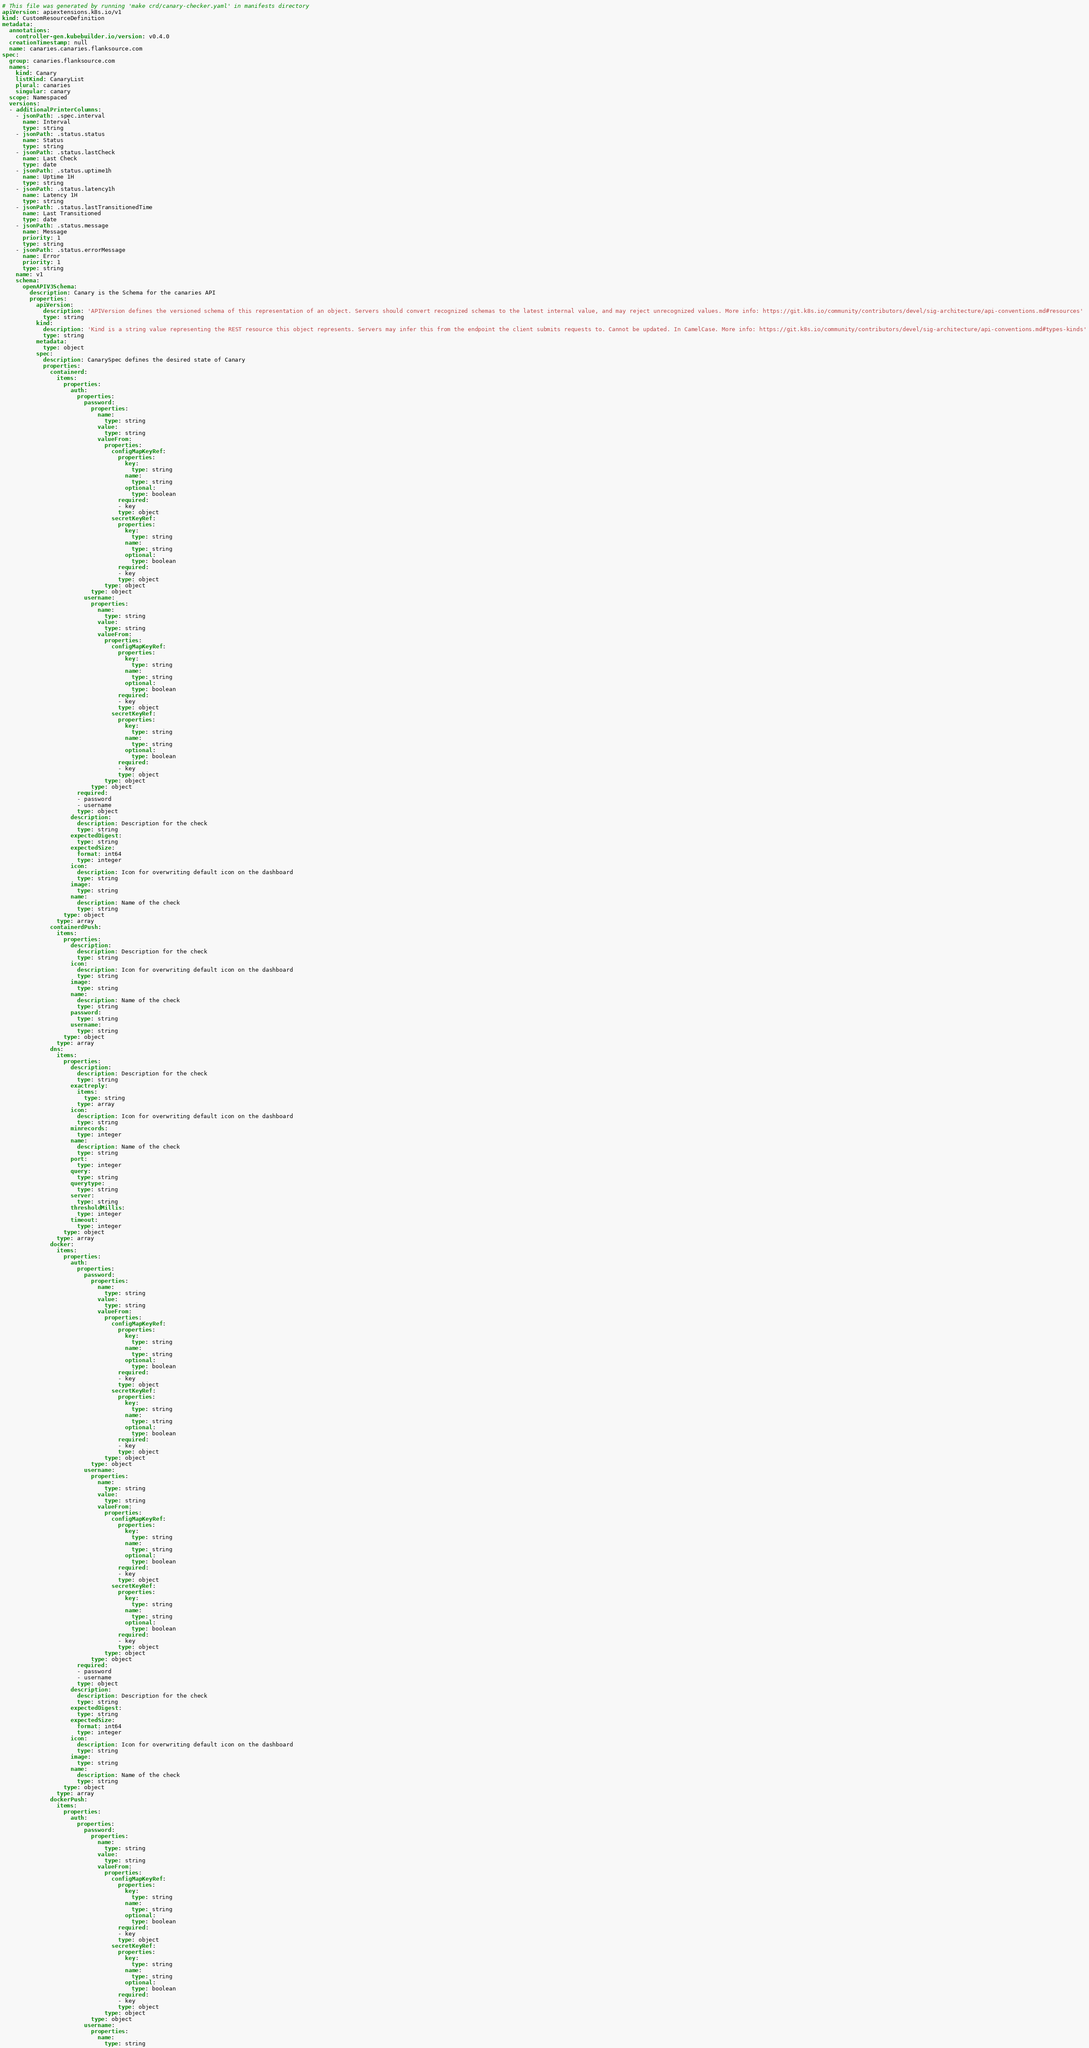Convert code to text. <code><loc_0><loc_0><loc_500><loc_500><_YAML_># This file was generated by running 'make crd/canary-checker.yaml' in manifests directory
apiVersion: apiextensions.k8s.io/v1
kind: CustomResourceDefinition
metadata:
  annotations:
    controller-gen.kubebuilder.io/version: v0.4.0
  creationTimestamp: null
  name: canaries.canaries.flanksource.com
spec:
  group: canaries.flanksource.com
  names:
    kind: Canary
    listKind: CanaryList
    plural: canaries
    singular: canary
  scope: Namespaced
  versions:
  - additionalPrinterColumns:
    - jsonPath: .spec.interval
      name: Interval
      type: string
    - jsonPath: .status.status
      name: Status
      type: string
    - jsonPath: .status.lastCheck
      name: Last Check
      type: date
    - jsonPath: .status.uptime1h
      name: Uptime 1H
      type: string
    - jsonPath: .status.latency1h
      name: Latency 1H
      type: string
    - jsonPath: .status.lastTransitionedTime
      name: Last Transitioned
      type: date
    - jsonPath: .status.message
      name: Message
      priority: 1
      type: string
    - jsonPath: .status.errorMessage
      name: Error
      priority: 1
      type: string
    name: v1
    schema:
      openAPIV3Schema:
        description: Canary is the Schema for the canaries API
        properties:
          apiVersion:
            description: 'APIVersion defines the versioned schema of this representation of an object. Servers should convert recognized schemas to the latest internal value, and may reject unrecognized values. More info: https://git.k8s.io/community/contributors/devel/sig-architecture/api-conventions.md#resources'
            type: string
          kind:
            description: 'Kind is a string value representing the REST resource this object represents. Servers may infer this from the endpoint the client submits requests to. Cannot be updated. In CamelCase. More info: https://git.k8s.io/community/contributors/devel/sig-architecture/api-conventions.md#types-kinds'
            type: string
          metadata:
            type: object
          spec:
            description: CanarySpec defines the desired state of Canary
            properties:
              containerd:
                items:
                  properties:
                    auth:
                      properties:
                        password:
                          properties:
                            name:
                              type: string
                            value:
                              type: string
                            valueFrom:
                              properties:
                                configMapKeyRef:
                                  properties:
                                    key:
                                      type: string
                                    name:
                                      type: string
                                    optional:
                                      type: boolean
                                  required:
                                  - key
                                  type: object
                                secretKeyRef:
                                  properties:
                                    key:
                                      type: string
                                    name:
                                      type: string
                                    optional:
                                      type: boolean
                                  required:
                                  - key
                                  type: object
                              type: object
                          type: object
                        username:
                          properties:
                            name:
                              type: string
                            value:
                              type: string
                            valueFrom:
                              properties:
                                configMapKeyRef:
                                  properties:
                                    key:
                                      type: string
                                    name:
                                      type: string
                                    optional:
                                      type: boolean
                                  required:
                                  - key
                                  type: object
                                secretKeyRef:
                                  properties:
                                    key:
                                      type: string
                                    name:
                                      type: string
                                    optional:
                                      type: boolean
                                  required:
                                  - key
                                  type: object
                              type: object
                          type: object
                      required:
                      - password
                      - username
                      type: object
                    description:
                      description: Description for the check
                      type: string
                    expectedDigest:
                      type: string
                    expectedSize:
                      format: int64
                      type: integer
                    icon:
                      description: Icon for overwriting default icon on the dashboard
                      type: string
                    image:
                      type: string
                    name:
                      description: Name of the check
                      type: string
                  type: object
                type: array
              containerdPush:
                items:
                  properties:
                    description:
                      description: Description for the check
                      type: string
                    icon:
                      description: Icon for overwriting default icon on the dashboard
                      type: string
                    image:
                      type: string
                    name:
                      description: Name of the check
                      type: string
                    password:
                      type: string
                    username:
                      type: string
                  type: object
                type: array
              dns:
                items:
                  properties:
                    description:
                      description: Description for the check
                      type: string
                    exactreply:
                      items:
                        type: string
                      type: array
                    icon:
                      description: Icon for overwriting default icon on the dashboard
                      type: string
                    minrecords:
                      type: integer
                    name:
                      description: Name of the check
                      type: string
                    port:
                      type: integer
                    query:
                      type: string
                    querytype:
                      type: string
                    server:
                      type: string
                    thresholdMillis:
                      type: integer
                    timeout:
                      type: integer
                  type: object
                type: array
              docker:
                items:
                  properties:
                    auth:
                      properties:
                        password:
                          properties:
                            name:
                              type: string
                            value:
                              type: string
                            valueFrom:
                              properties:
                                configMapKeyRef:
                                  properties:
                                    key:
                                      type: string
                                    name:
                                      type: string
                                    optional:
                                      type: boolean
                                  required:
                                  - key
                                  type: object
                                secretKeyRef:
                                  properties:
                                    key:
                                      type: string
                                    name:
                                      type: string
                                    optional:
                                      type: boolean
                                  required:
                                  - key
                                  type: object
                              type: object
                          type: object
                        username:
                          properties:
                            name:
                              type: string
                            value:
                              type: string
                            valueFrom:
                              properties:
                                configMapKeyRef:
                                  properties:
                                    key:
                                      type: string
                                    name:
                                      type: string
                                    optional:
                                      type: boolean
                                  required:
                                  - key
                                  type: object
                                secretKeyRef:
                                  properties:
                                    key:
                                      type: string
                                    name:
                                      type: string
                                    optional:
                                      type: boolean
                                  required:
                                  - key
                                  type: object
                              type: object
                          type: object
                      required:
                      - password
                      - username
                      type: object
                    description:
                      description: Description for the check
                      type: string
                    expectedDigest:
                      type: string
                    expectedSize:
                      format: int64
                      type: integer
                    icon:
                      description: Icon for overwriting default icon on the dashboard
                      type: string
                    image:
                      type: string
                    name:
                      description: Name of the check
                      type: string
                  type: object
                type: array
              dockerPush:
                items:
                  properties:
                    auth:
                      properties:
                        password:
                          properties:
                            name:
                              type: string
                            value:
                              type: string
                            valueFrom:
                              properties:
                                configMapKeyRef:
                                  properties:
                                    key:
                                      type: string
                                    name:
                                      type: string
                                    optional:
                                      type: boolean
                                  required:
                                  - key
                                  type: object
                                secretKeyRef:
                                  properties:
                                    key:
                                      type: string
                                    name:
                                      type: string
                                    optional:
                                      type: boolean
                                  required:
                                  - key
                                  type: object
                              type: object
                          type: object
                        username:
                          properties:
                            name:
                              type: string</code> 